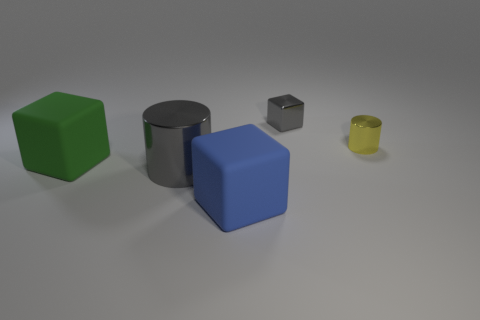Are there any big gray things of the same shape as the large blue object?
Make the answer very short. No. Does the big blue rubber thing have the same shape as the green thing?
Your answer should be compact. Yes. What is the color of the big rubber thing behind the gray metal thing that is to the left of the big blue matte block?
Give a very brief answer. Green. There is a object that is the same size as the gray metallic cube; what is its color?
Offer a very short reply. Yellow. What number of matte things are big things or large purple blocks?
Your response must be concise. 2. What number of blue matte objects are on the right side of the large matte block behind the blue rubber cube?
Offer a very short reply. 1. The metallic object that is the same color as the small block is what size?
Make the answer very short. Large. What number of things are either big red rubber cylinders or metal things that are to the left of the metal block?
Provide a succinct answer. 1. Is there a red block made of the same material as the gray cube?
Your answer should be very brief. No. What number of blocks are in front of the tiny metallic cylinder and behind the large gray metallic thing?
Provide a short and direct response. 1. 